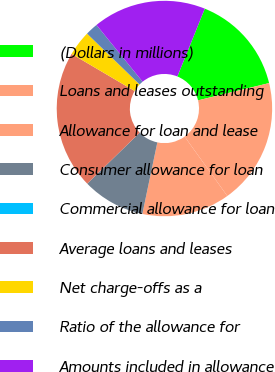<chart> <loc_0><loc_0><loc_500><loc_500><pie_chart><fcel>(Dollars in millions)<fcel>Loans and leases outstanding<fcel>Allowance for loan and lease<fcel>Consumer allowance for loan<fcel>Commercial allowance for loan<fcel>Average loans and leases<fcel>Net charge-offs as a<fcel>Ratio of the allowance for<fcel>Amounts included in allowance<nl><fcel>15.09%<fcel>18.87%<fcel>13.21%<fcel>9.43%<fcel>0.0%<fcel>20.75%<fcel>3.77%<fcel>1.89%<fcel>16.98%<nl></chart> 